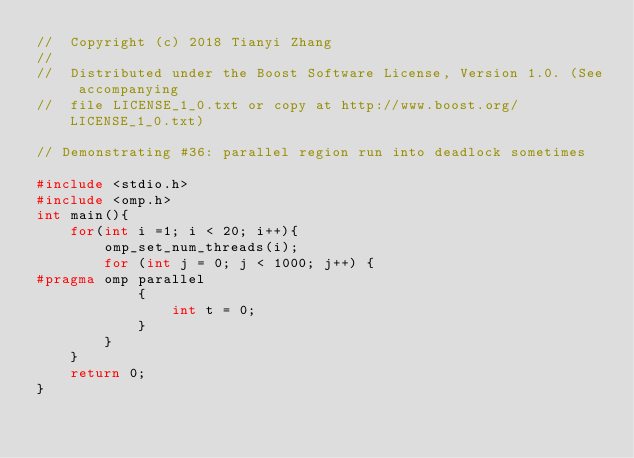Convert code to text. <code><loc_0><loc_0><loc_500><loc_500><_C++_>//  Copyright (c) 2018 Tianyi Zhang
//
//  Distributed under the Boost Software License, Version 1.0. (See accompanying
//  file LICENSE_1_0.txt or copy at http://www.boost.org/LICENSE_1_0.txt)

// Demonstrating #36: parallel region run into deadlock sometimes

#include <stdio.h>
#include <omp.h>
int main(){
    for(int i =1; i < 20; i++){
        omp_set_num_threads(i);
        for (int j = 0; j < 1000; j++) {
#pragma omp parallel
            {
                int t = 0;
            }
        }
    }
    return 0;
}
</code> 